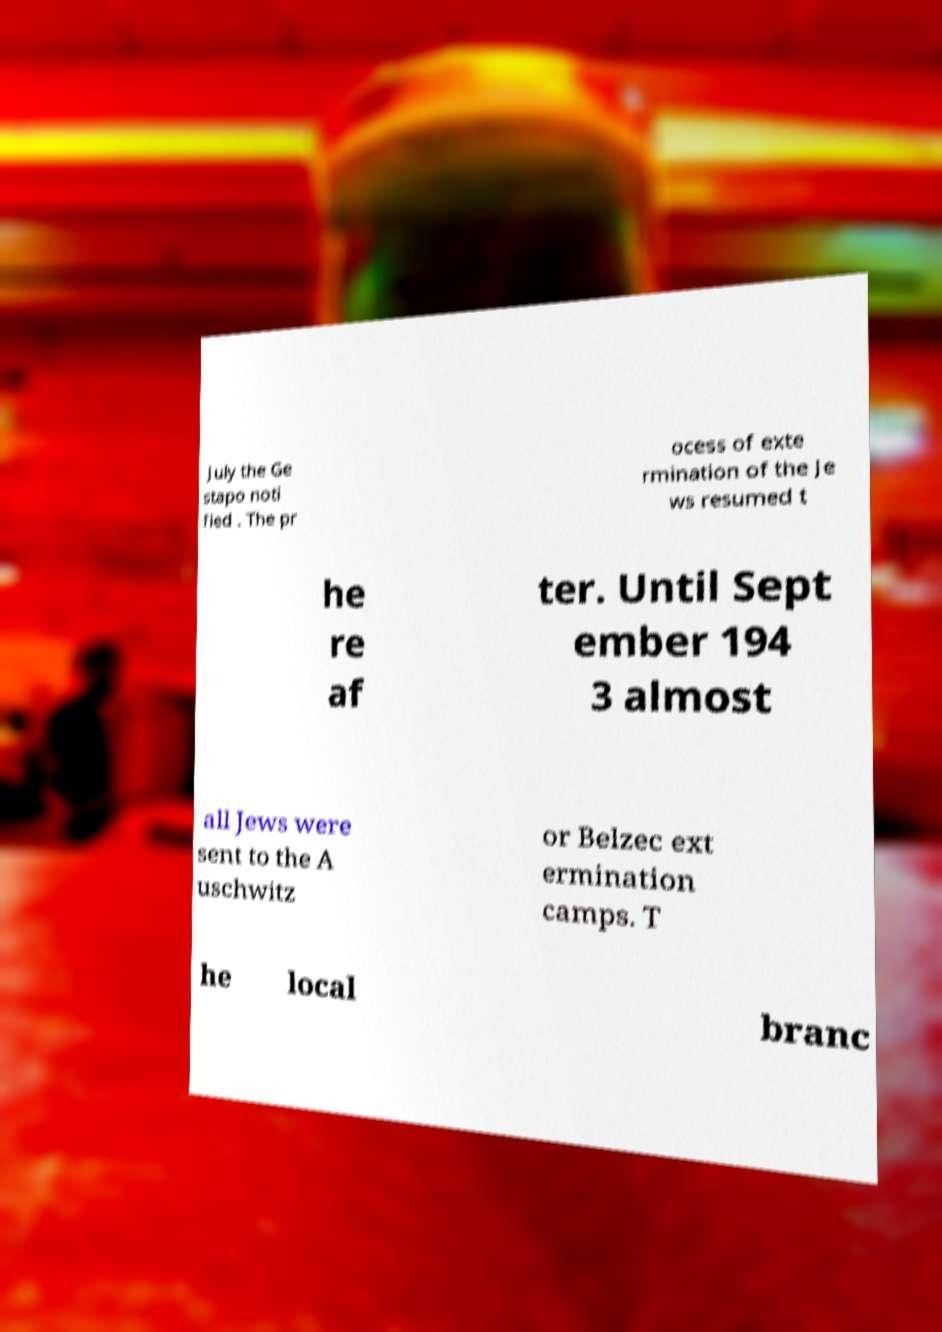What messages or text are displayed in this image? I need them in a readable, typed format. July the Ge stapo noti fied . The pr ocess of exte rmination of the Je ws resumed t he re af ter. Until Sept ember 194 3 almost all Jews were sent to the A uschwitz or Belzec ext ermination camps. T he local branc 